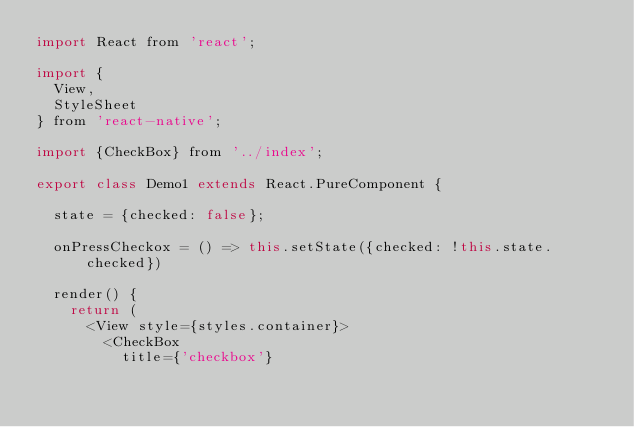Convert code to text. <code><loc_0><loc_0><loc_500><loc_500><_JavaScript_>import React from 'react';

import {
  View,
  StyleSheet
} from 'react-native';

import {CheckBox} from '../index';

export class Demo1 extends React.PureComponent {
  
  state = {checked: false};
  
  onPressCheckox = () => this.setState({checked: !this.state.checked})
  
  render() {
    return (
      <View style={styles.container}>
        <CheckBox
          title={'checkbox'}</code> 